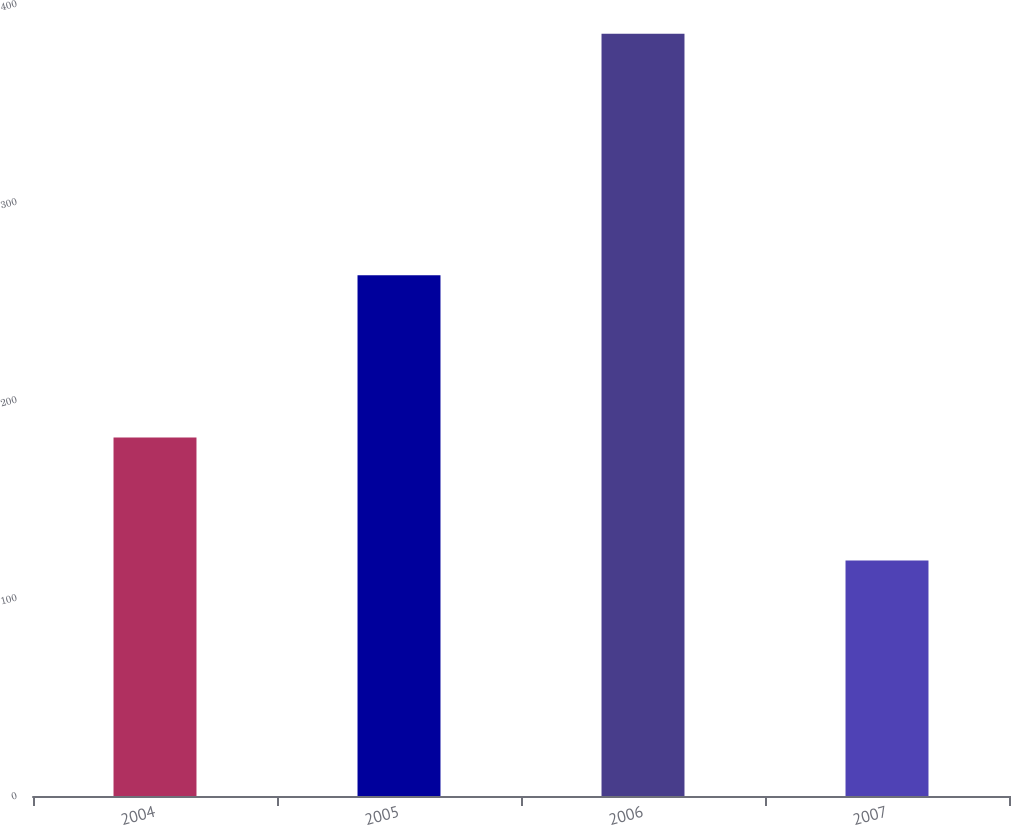Convert chart to OTSL. <chart><loc_0><loc_0><loc_500><loc_500><bar_chart><fcel>2004<fcel>2005<fcel>2006<fcel>2007<nl><fcel>181<fcel>263<fcel>385<fcel>119<nl></chart> 